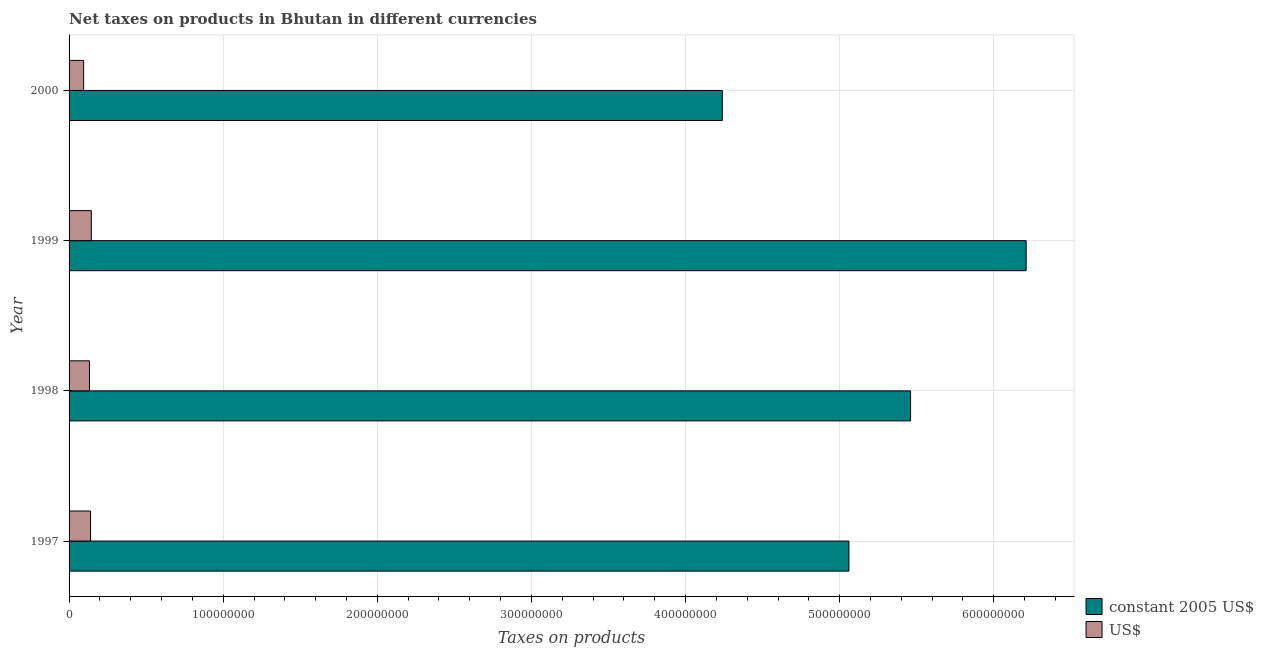How many groups of bars are there?
Keep it short and to the point. 4. Are the number of bars on each tick of the Y-axis equal?
Provide a short and direct response. Yes. How many bars are there on the 1st tick from the top?
Keep it short and to the point. 2. How many bars are there on the 3rd tick from the bottom?
Your answer should be compact. 2. What is the label of the 1st group of bars from the top?
Keep it short and to the point. 2000. What is the net taxes in constant 2005 us$ in 1998?
Your answer should be compact. 5.46e+08. Across all years, what is the maximum net taxes in constant 2005 us$?
Keep it short and to the point. 6.21e+08. Across all years, what is the minimum net taxes in us$?
Make the answer very short. 9.43e+06. In which year was the net taxes in constant 2005 us$ maximum?
Give a very brief answer. 1999. In which year was the net taxes in us$ minimum?
Your answer should be very brief. 2000. What is the total net taxes in us$ in the graph?
Provide a short and direct response. 5.10e+07. What is the difference between the net taxes in us$ in 1997 and that in 1998?
Offer a very short reply. 7.02e+05. What is the difference between the net taxes in constant 2005 us$ in 2000 and the net taxes in us$ in 1998?
Your answer should be compact. 4.11e+08. What is the average net taxes in constant 2005 us$ per year?
Your answer should be very brief. 5.24e+08. In the year 1998, what is the difference between the net taxes in us$ and net taxes in constant 2005 us$?
Your answer should be compact. -5.33e+08. In how many years, is the net taxes in constant 2005 us$ greater than 580000000 units?
Ensure brevity in your answer.  1. What is the ratio of the net taxes in us$ in 1999 to that in 2000?
Ensure brevity in your answer.  1.53. Is the net taxes in constant 2005 us$ in 1997 less than that in 2000?
Give a very brief answer. No. Is the difference between the net taxes in constant 2005 us$ in 1997 and 1999 greater than the difference between the net taxes in us$ in 1997 and 1999?
Your answer should be compact. No. What is the difference between the highest and the second highest net taxes in constant 2005 us$?
Provide a short and direct response. 7.50e+07. What is the difference between the highest and the lowest net taxes in us$?
Provide a short and direct response. 4.99e+06. What does the 2nd bar from the top in 2000 represents?
Provide a succinct answer. Constant 2005 us$. What does the 2nd bar from the bottom in 1998 represents?
Your answer should be compact. US$. Are all the bars in the graph horizontal?
Your answer should be compact. Yes. How many years are there in the graph?
Make the answer very short. 4. Does the graph contain any zero values?
Ensure brevity in your answer.  No. Where does the legend appear in the graph?
Ensure brevity in your answer.  Bottom right. How many legend labels are there?
Provide a succinct answer. 2. What is the title of the graph?
Offer a terse response. Net taxes on products in Bhutan in different currencies. What is the label or title of the X-axis?
Provide a succinct answer. Taxes on products. What is the Taxes on products in constant 2005 US$ in 1997?
Your response must be concise. 5.06e+08. What is the Taxes on products in US$ in 1997?
Your answer should be very brief. 1.39e+07. What is the Taxes on products of constant 2005 US$ in 1998?
Ensure brevity in your answer.  5.46e+08. What is the Taxes on products of US$ in 1998?
Give a very brief answer. 1.32e+07. What is the Taxes on products of constant 2005 US$ in 1999?
Your response must be concise. 6.21e+08. What is the Taxes on products of US$ in 1999?
Offer a terse response. 1.44e+07. What is the Taxes on products of constant 2005 US$ in 2000?
Your answer should be compact. 4.24e+08. What is the Taxes on products of US$ in 2000?
Offer a very short reply. 9.43e+06. Across all years, what is the maximum Taxes on products of constant 2005 US$?
Make the answer very short. 6.21e+08. Across all years, what is the maximum Taxes on products in US$?
Keep it short and to the point. 1.44e+07. Across all years, what is the minimum Taxes on products in constant 2005 US$?
Keep it short and to the point. 4.24e+08. Across all years, what is the minimum Taxes on products in US$?
Offer a terse response. 9.43e+06. What is the total Taxes on products in constant 2005 US$ in the graph?
Provide a short and direct response. 2.10e+09. What is the total Taxes on products in US$ in the graph?
Your response must be concise. 5.10e+07. What is the difference between the Taxes on products in constant 2005 US$ in 1997 and that in 1998?
Offer a very short reply. -4.00e+07. What is the difference between the Taxes on products of US$ in 1997 and that in 1998?
Offer a very short reply. 7.02e+05. What is the difference between the Taxes on products in constant 2005 US$ in 1997 and that in 1999?
Make the answer very short. -1.15e+08. What is the difference between the Taxes on products of US$ in 1997 and that in 1999?
Offer a terse response. -4.86e+05. What is the difference between the Taxes on products in constant 2005 US$ in 1997 and that in 2000?
Provide a succinct answer. 8.22e+07. What is the difference between the Taxes on products in US$ in 1997 and that in 2000?
Offer a terse response. 4.50e+06. What is the difference between the Taxes on products in constant 2005 US$ in 1998 and that in 1999?
Make the answer very short. -7.50e+07. What is the difference between the Taxes on products of US$ in 1998 and that in 1999?
Ensure brevity in your answer.  -1.19e+06. What is the difference between the Taxes on products of constant 2005 US$ in 1998 and that in 2000?
Your response must be concise. 1.22e+08. What is the difference between the Taxes on products in US$ in 1998 and that in 2000?
Keep it short and to the point. 3.80e+06. What is the difference between the Taxes on products of constant 2005 US$ in 1999 and that in 2000?
Your response must be concise. 1.97e+08. What is the difference between the Taxes on products in US$ in 1999 and that in 2000?
Your answer should be very brief. 4.99e+06. What is the difference between the Taxes on products of constant 2005 US$ in 1997 and the Taxes on products of US$ in 1998?
Keep it short and to the point. 4.93e+08. What is the difference between the Taxes on products in constant 2005 US$ in 1997 and the Taxes on products in US$ in 1999?
Give a very brief answer. 4.92e+08. What is the difference between the Taxes on products in constant 2005 US$ in 1997 and the Taxes on products in US$ in 2000?
Make the answer very short. 4.97e+08. What is the difference between the Taxes on products of constant 2005 US$ in 1998 and the Taxes on products of US$ in 1999?
Your response must be concise. 5.32e+08. What is the difference between the Taxes on products of constant 2005 US$ in 1998 and the Taxes on products of US$ in 2000?
Your answer should be very brief. 5.37e+08. What is the difference between the Taxes on products in constant 2005 US$ in 1999 and the Taxes on products in US$ in 2000?
Your response must be concise. 6.12e+08. What is the average Taxes on products of constant 2005 US$ per year?
Your answer should be very brief. 5.24e+08. What is the average Taxes on products of US$ per year?
Give a very brief answer. 1.28e+07. In the year 1997, what is the difference between the Taxes on products in constant 2005 US$ and Taxes on products in US$?
Provide a succinct answer. 4.92e+08. In the year 1998, what is the difference between the Taxes on products of constant 2005 US$ and Taxes on products of US$?
Provide a succinct answer. 5.33e+08. In the year 1999, what is the difference between the Taxes on products of constant 2005 US$ and Taxes on products of US$?
Ensure brevity in your answer.  6.07e+08. In the year 2000, what is the difference between the Taxes on products of constant 2005 US$ and Taxes on products of US$?
Give a very brief answer. 4.14e+08. What is the ratio of the Taxes on products in constant 2005 US$ in 1997 to that in 1998?
Your answer should be compact. 0.93. What is the ratio of the Taxes on products in US$ in 1997 to that in 1998?
Your response must be concise. 1.05. What is the ratio of the Taxes on products in constant 2005 US$ in 1997 to that in 1999?
Provide a short and direct response. 0.81. What is the ratio of the Taxes on products of US$ in 1997 to that in 1999?
Your response must be concise. 0.97. What is the ratio of the Taxes on products of constant 2005 US$ in 1997 to that in 2000?
Offer a terse response. 1.19. What is the ratio of the Taxes on products of US$ in 1997 to that in 2000?
Your answer should be compact. 1.48. What is the ratio of the Taxes on products in constant 2005 US$ in 1998 to that in 1999?
Provide a short and direct response. 0.88. What is the ratio of the Taxes on products in US$ in 1998 to that in 1999?
Provide a succinct answer. 0.92. What is the ratio of the Taxes on products in constant 2005 US$ in 1998 to that in 2000?
Keep it short and to the point. 1.29. What is the ratio of the Taxes on products of US$ in 1998 to that in 2000?
Offer a terse response. 1.4. What is the ratio of the Taxes on products of constant 2005 US$ in 1999 to that in 2000?
Ensure brevity in your answer.  1.47. What is the ratio of the Taxes on products in US$ in 1999 to that in 2000?
Your answer should be compact. 1.53. What is the difference between the highest and the second highest Taxes on products in constant 2005 US$?
Your answer should be very brief. 7.50e+07. What is the difference between the highest and the second highest Taxes on products in US$?
Keep it short and to the point. 4.86e+05. What is the difference between the highest and the lowest Taxes on products of constant 2005 US$?
Your response must be concise. 1.97e+08. What is the difference between the highest and the lowest Taxes on products of US$?
Keep it short and to the point. 4.99e+06. 